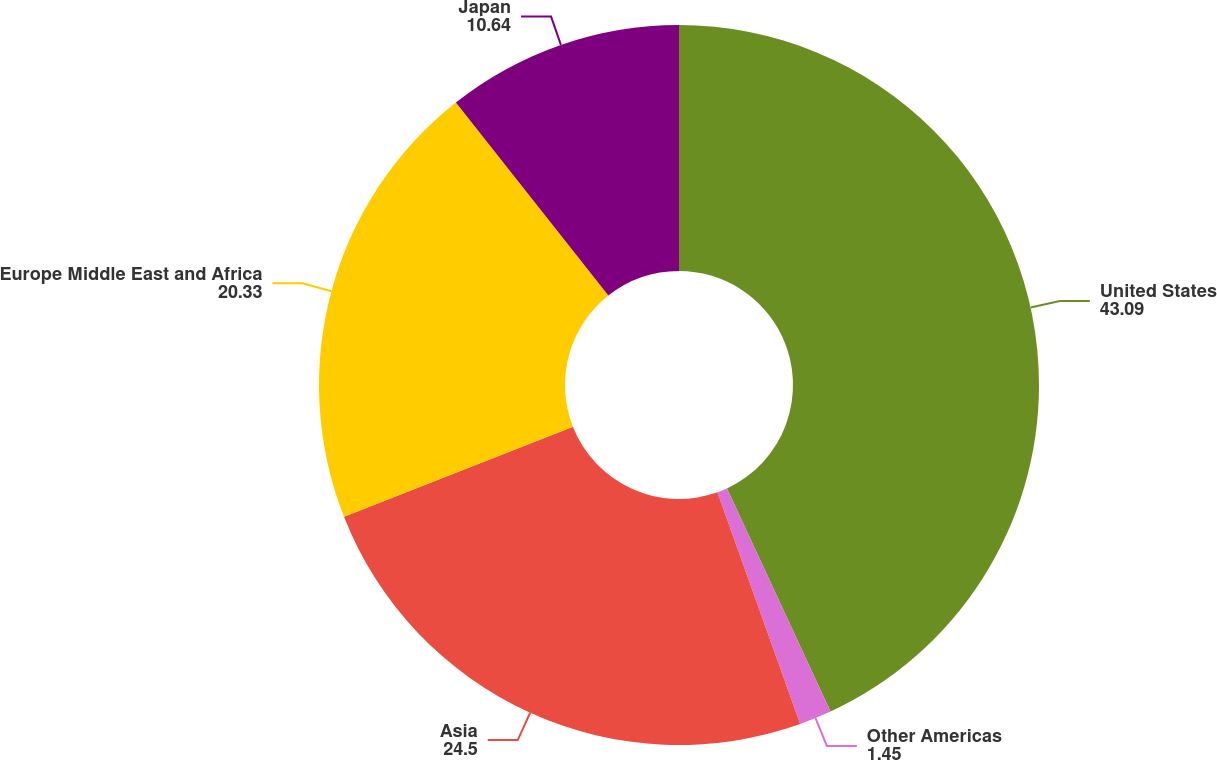Convert chart. <chart><loc_0><loc_0><loc_500><loc_500><pie_chart><fcel>United States<fcel>Other Americas<fcel>Asia<fcel>Europe Middle East and Africa<fcel>Japan<nl><fcel>43.09%<fcel>1.45%<fcel>24.5%<fcel>20.33%<fcel>10.64%<nl></chart> 